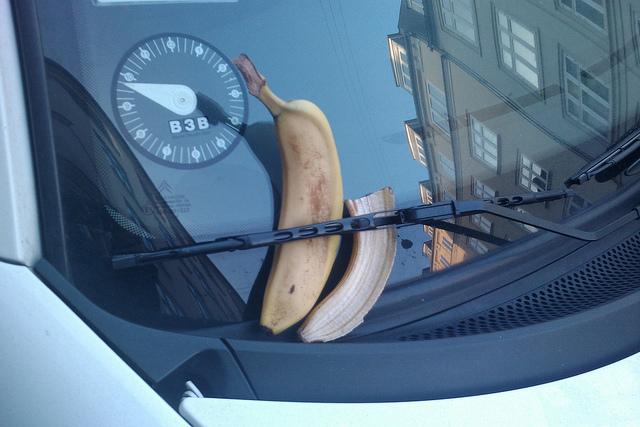Did someone only eat half a banana?
Short answer required. Yes. What kind of fruit is on the windshield?
Be succinct. Banana. What color is the banana?
Be succinct. Yellow. 